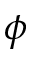Convert formula to latex. <formula><loc_0><loc_0><loc_500><loc_500>\phi</formula> 